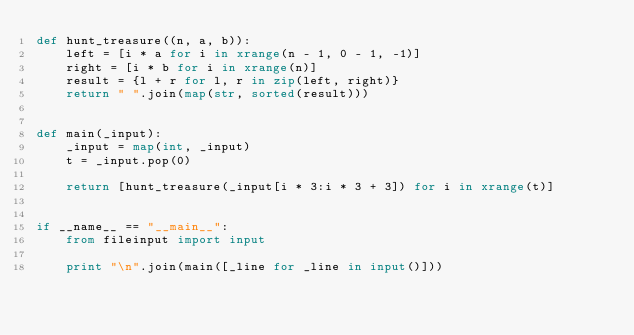Convert code to text. <code><loc_0><loc_0><loc_500><loc_500><_Python_>def hunt_treasure((n, a, b)):
    left = [i * a for i in xrange(n - 1, 0 - 1, -1)]
    right = [i * b for i in xrange(n)]
    result = {l + r for l, r in zip(left, right)}
    return " ".join(map(str, sorted(result)))


def main(_input):
    _input = map(int, _input)
    t = _input.pop(0)

    return [hunt_treasure(_input[i * 3:i * 3 + 3]) for i in xrange(t)]


if __name__ == "__main__":
    from fileinput import input

    print "\n".join(main([_line for _line in input()]))
</code> 